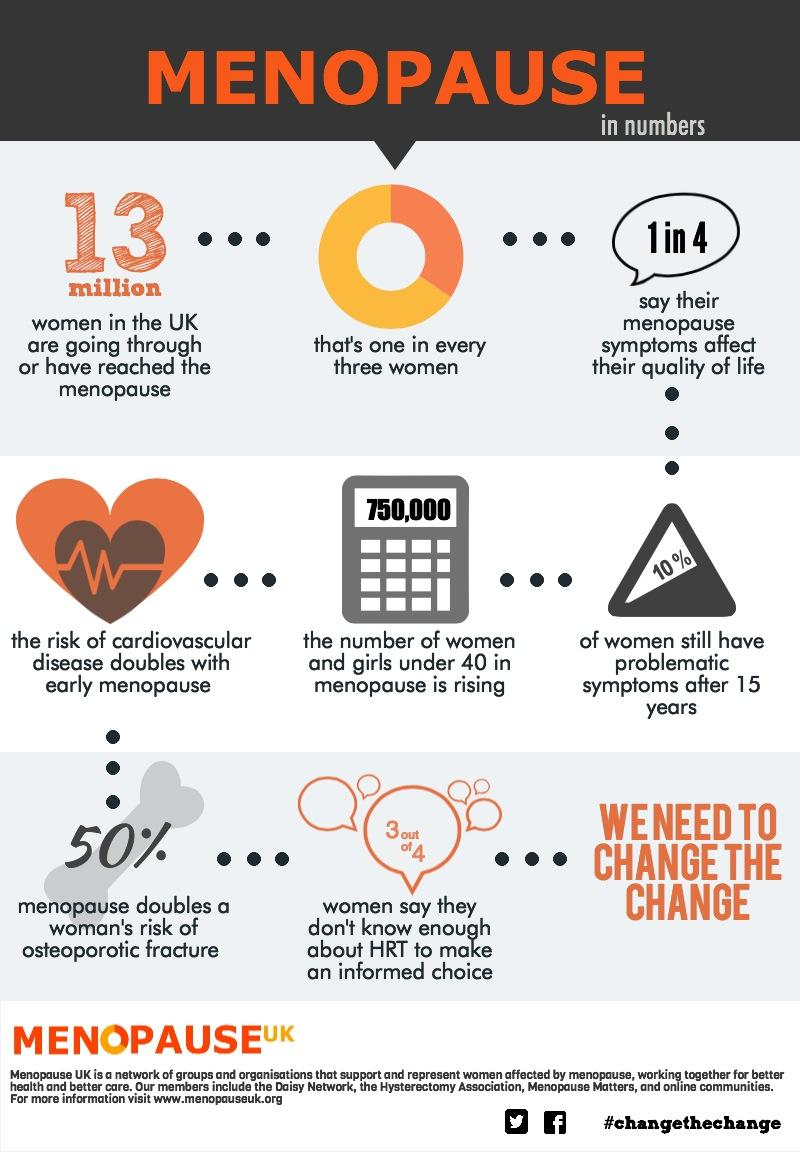Point out several critical features in this image. Research suggests that approximately 13 million women in the United Kingdom are currently going through or have reached the menopause. According to studies, menopause can double a woman's risk of osteoporotic fracture, with the percentage being estimated to be around 50%. In the United Kingdom, it is reported that only 10% of women experience problematic symptoms after menopause. 